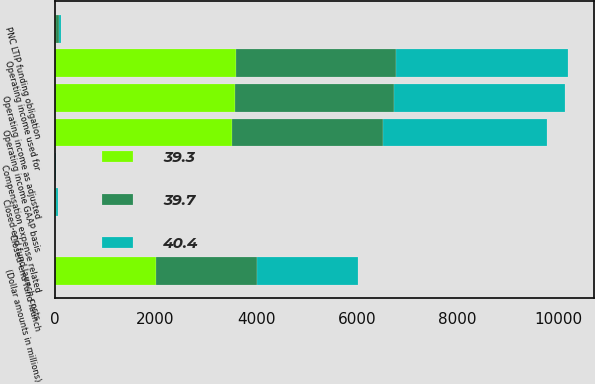Convert chart. <chart><loc_0><loc_0><loc_500><loc_500><stacked_bar_chart><ecel><fcel>(Dollar amounts in millions)<fcel>Operating income GAAP basis<fcel>PNC LTIP funding obligation<fcel>Compensation expense related<fcel>Operating income as adjusted<fcel>Closed-end fund launch costs<fcel>Closed-end fund launch<fcel>Operating income used for<nl><fcel>39.3<fcel>2012<fcel>3524<fcel>22<fcel>6<fcel>3574<fcel>22<fcel>3<fcel>3599<nl><fcel>40.4<fcel>2011<fcel>3249<fcel>44<fcel>3<fcel>3392<fcel>26<fcel>3<fcel>3421<nl><fcel>39.7<fcel>2010<fcel>2998<fcel>58<fcel>11<fcel>3167<fcel>15<fcel>2<fcel>3184<nl></chart> 